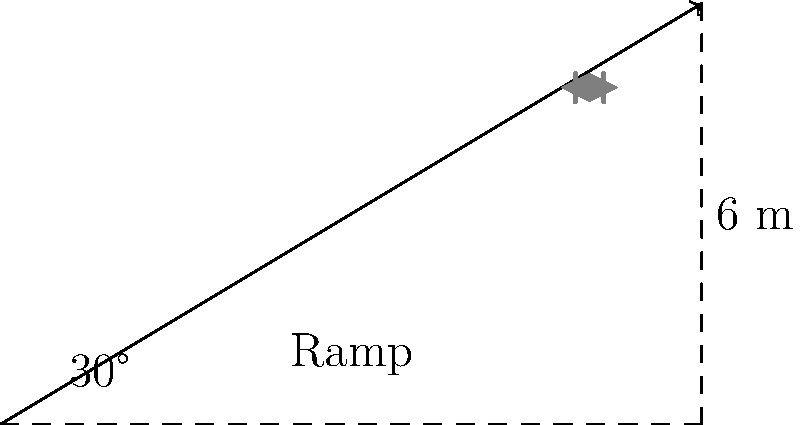A skateboarder starts from rest at the top of a ramp that is 6 meters high and forms a 30° angle with the horizontal. Assuming there is no friction, what is the skateboarder's velocity at the bottom of the ramp? (Use $g = 9.8 \text{ m/s}^2$) Let's approach this step-by-step using the principle of conservation of energy:

1) At the top of the ramp, the skateboarder has only potential energy (PE). At the bottom, this has been converted to kinetic energy (KE).

2) The initial potential energy is:
   $PE = mgh$, where $m$ is mass, $g$ is acceleration due to gravity, and $h$ is height.

3) The final kinetic energy is:
   $KE = \frac{1}{2}mv^2$, where $v$ is velocity.

4) According to conservation of energy:
   $PE_{\text{initial}} = KE_{\text{final}}$
   $mgh = \frac{1}{2}mv^2$

5) The mass $m$ cancels out on both sides:
   $gh = \frac{1}{2}v^2$

6) Solve for $v$:
   $v = \sqrt{2gh}$

7) Plug in the values:
   $v = \sqrt{2 \cdot 9.8 \text{ m/s}^2 \cdot 6 \text{ m}}$

8) Calculate:
   $v = \sqrt{117.6 \text{ m}^2/\text{s}^2} = 10.84 \text{ m/s}$

Therefore, the skateboarder's velocity at the bottom of the ramp is approximately 10.84 m/s.
Answer: 10.84 m/s 